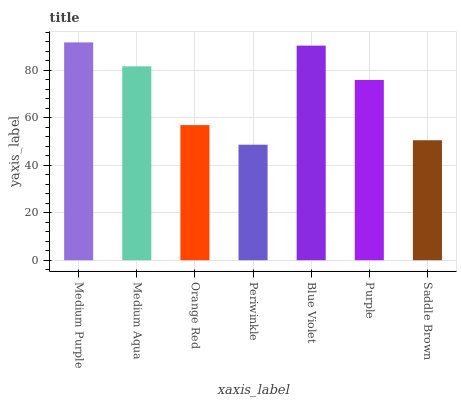Is Medium Aqua the minimum?
Answer yes or no. No. Is Medium Aqua the maximum?
Answer yes or no. No. Is Medium Purple greater than Medium Aqua?
Answer yes or no. Yes. Is Medium Aqua less than Medium Purple?
Answer yes or no. Yes. Is Medium Aqua greater than Medium Purple?
Answer yes or no. No. Is Medium Purple less than Medium Aqua?
Answer yes or no. No. Is Purple the high median?
Answer yes or no. Yes. Is Purple the low median?
Answer yes or no. Yes. Is Medium Aqua the high median?
Answer yes or no. No. Is Saddle Brown the low median?
Answer yes or no. No. 